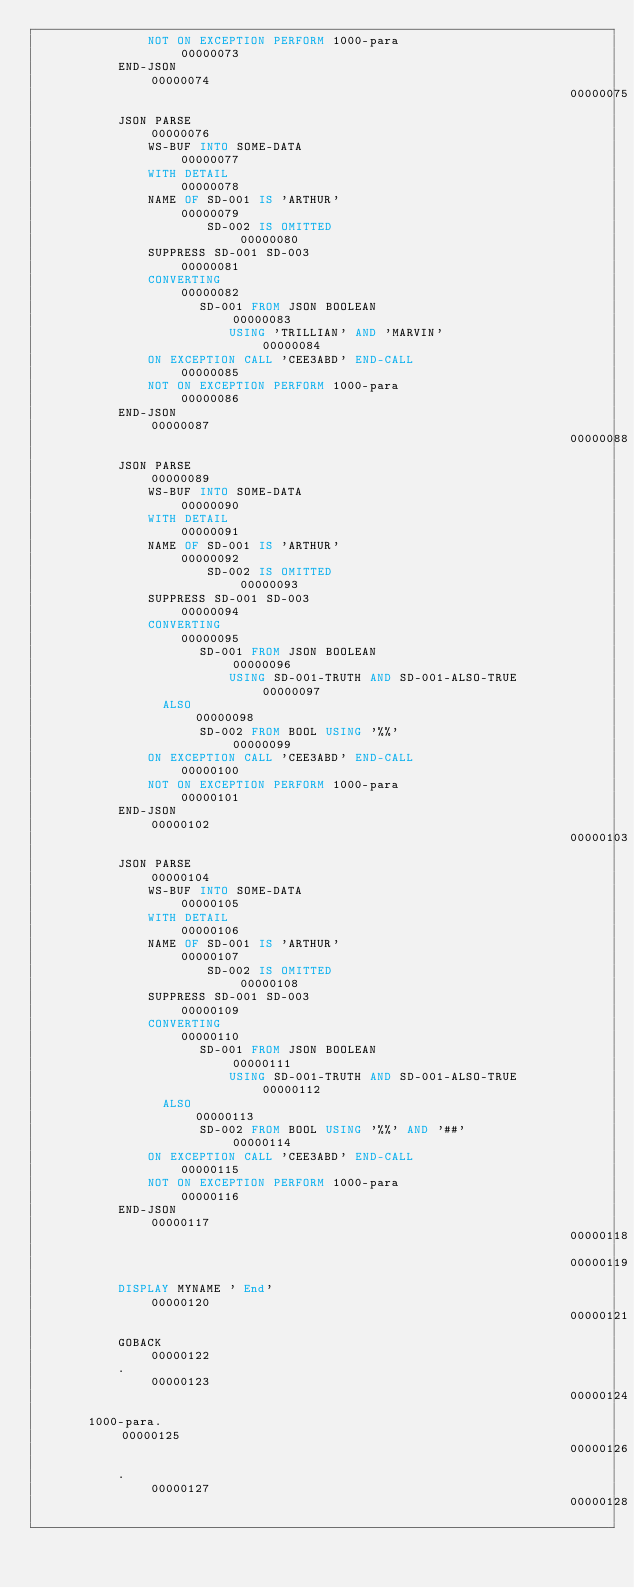Convert code to text. <code><loc_0><loc_0><loc_500><loc_500><_COBOL_>               NOT ON EXCEPTION PERFORM 1000-para                       00000073
           END-JSON                                                     00000074
                                                                        00000075
           JSON PARSE                                                   00000076
               WS-BUF INTO SOME-DATA                                    00000077
               WITH DETAIL                                              00000078
               NAME OF SD-001 IS 'ARTHUR'                               00000079
                       SD-002 IS OMITTED                                00000080
               SUPPRESS SD-001 SD-003                                   00000081
               CONVERTING                                               00000082
                      SD-001 FROM JSON BOOLEAN                          00000083
                          USING 'TRILLIAN' AND 'MARVIN'                 00000084
               ON EXCEPTION CALL 'CEE3ABD' END-CALL                     00000085
               NOT ON EXCEPTION PERFORM 1000-para                       00000086
           END-JSON                                                     00000087
                                                                        00000088
           JSON PARSE                                                   00000089
               WS-BUF INTO SOME-DATA                                    00000090
               WITH DETAIL                                              00000091
               NAME OF SD-001 IS 'ARTHUR'                               00000092
                       SD-002 IS OMITTED                                00000093
               SUPPRESS SD-001 SD-003                                   00000094
               CONVERTING                                               00000095
                      SD-001 FROM JSON BOOLEAN                          00000096
                          USING SD-001-TRUTH AND SD-001-ALSO-TRUE       00000097
                 ALSO                                                   00000098
                      SD-002 FROM BOOL USING '%%'                       00000099
               ON EXCEPTION CALL 'CEE3ABD' END-CALL                     00000100
               NOT ON EXCEPTION PERFORM 1000-para                       00000101
           END-JSON                                                     00000102
                                                                        00000103
           JSON PARSE                                                   00000104
               WS-BUF INTO SOME-DATA                                    00000105
               WITH DETAIL                                              00000106
               NAME OF SD-001 IS 'ARTHUR'                               00000107
                       SD-002 IS OMITTED                                00000108
               SUPPRESS SD-001 SD-003                                   00000109
               CONVERTING                                               00000110
                      SD-001 FROM JSON BOOLEAN                          00000111
                          USING SD-001-TRUTH AND SD-001-ALSO-TRUE       00000112
                 ALSO                                                   00000113
                      SD-002 FROM BOOL USING '%%' AND '##'              00000114
               ON EXCEPTION CALL 'CEE3ABD' END-CALL                     00000115
               NOT ON EXCEPTION PERFORM 1000-para                       00000116
           END-JSON                                                     00000117
                                                                        00000118
                                                                        00000119
           DISPLAY MYNAME ' End'                                        00000120
                                                                        00000121
           GOBACK                                                       00000122
           .                                                            00000123
                                                                        00000124
       1000-para.                                                       00000125
                                                                        00000126
           .                                                            00000127
                                                                        00000128
</code> 